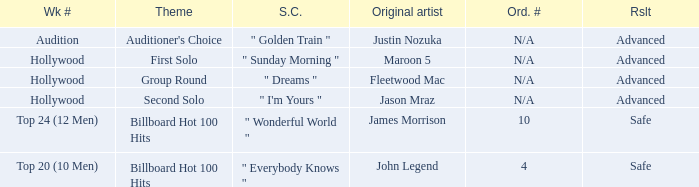What are all the results of songs is " golden train " Advanced. 